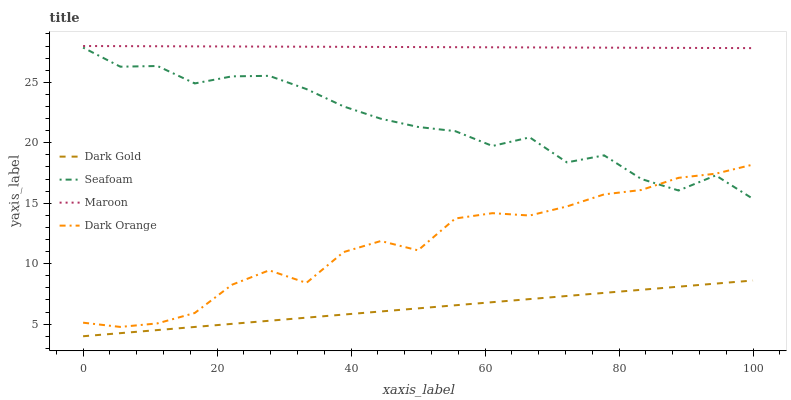Does Dark Gold have the minimum area under the curve?
Answer yes or no. Yes. Does Maroon have the maximum area under the curve?
Answer yes or no. Yes. Does Seafoam have the minimum area under the curve?
Answer yes or no. No. Does Seafoam have the maximum area under the curve?
Answer yes or no. No. Is Dark Gold the smoothest?
Answer yes or no. Yes. Is Seafoam the roughest?
Answer yes or no. Yes. Is Maroon the smoothest?
Answer yes or no. No. Is Maroon the roughest?
Answer yes or no. No. Does Dark Gold have the lowest value?
Answer yes or no. Yes. Does Seafoam have the lowest value?
Answer yes or no. No. Does Maroon have the highest value?
Answer yes or no. Yes. Does Seafoam have the highest value?
Answer yes or no. No. Is Dark Gold less than Maroon?
Answer yes or no. Yes. Is Dark Orange greater than Dark Gold?
Answer yes or no. Yes. Does Seafoam intersect Dark Orange?
Answer yes or no. Yes. Is Seafoam less than Dark Orange?
Answer yes or no. No. Is Seafoam greater than Dark Orange?
Answer yes or no. No. Does Dark Gold intersect Maroon?
Answer yes or no. No. 